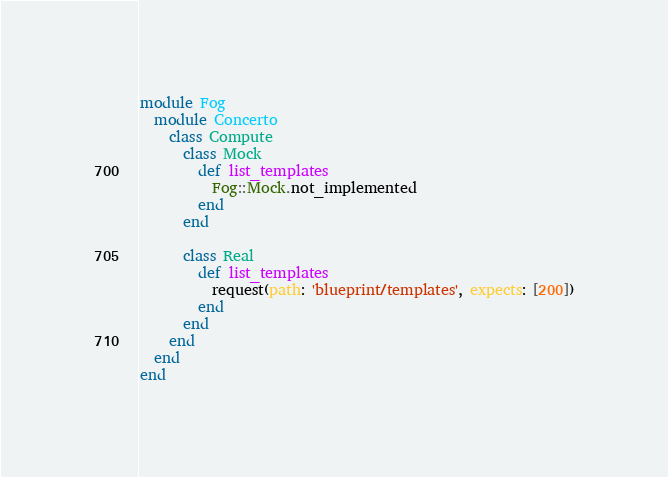Convert code to text. <code><loc_0><loc_0><loc_500><loc_500><_Ruby_>module Fog
  module Concerto
    class Compute
      class Mock
        def list_templates
          Fog::Mock.not_implemented
        end
      end

      class Real
        def list_templates
          request(path: 'blueprint/templates', expects: [200])
        end
      end
    end
  end
end
</code> 